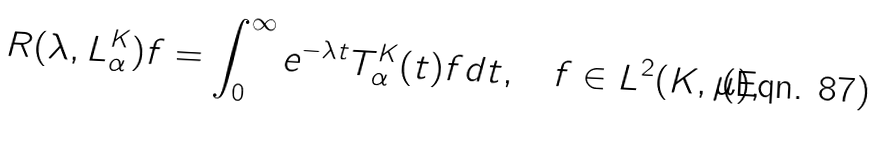<formula> <loc_0><loc_0><loc_500><loc_500>R ( \lambda , L ^ { K } _ { \alpha } ) f = \int _ { 0 } ^ { \infty } e ^ { - \lambda t } T ^ { K } _ { \alpha } ( t ) f d t , \quad f \in L ^ { 2 } ( K , \mu ) ,</formula> 